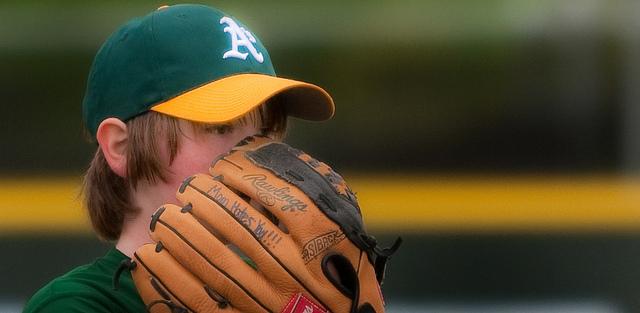What body part used to see is not covered by the glove?
Concise answer only. Eyes. What sport is he playing?
Give a very brief answer. Baseball. What team does he play on?
Concise answer only. A's. 